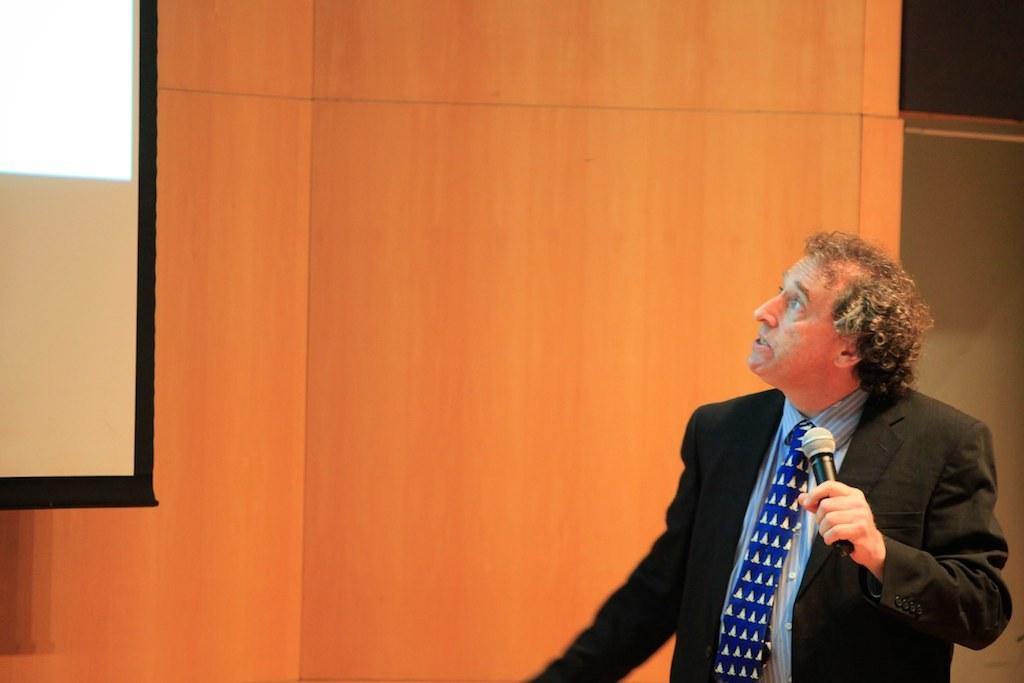What is the main subject of the image? The main subject of the image is a man. What is the man doing in the image? The man is standing and holding a microphone in his hand. What is the man looking at in the image? The man is looking towards a screen on the wall. What type of clothing is the man wearing in the image? The man is wearing a blazer, a tie, and a shirt. What direction is the man facing in the image? The provided facts do not specify the direction the man is facing, only that he is looking towards a screen on the wall. Is there a cellar visible in the image? There is no mention of a cellar in the provided facts, so it cannot be determined if one is present in the image. 